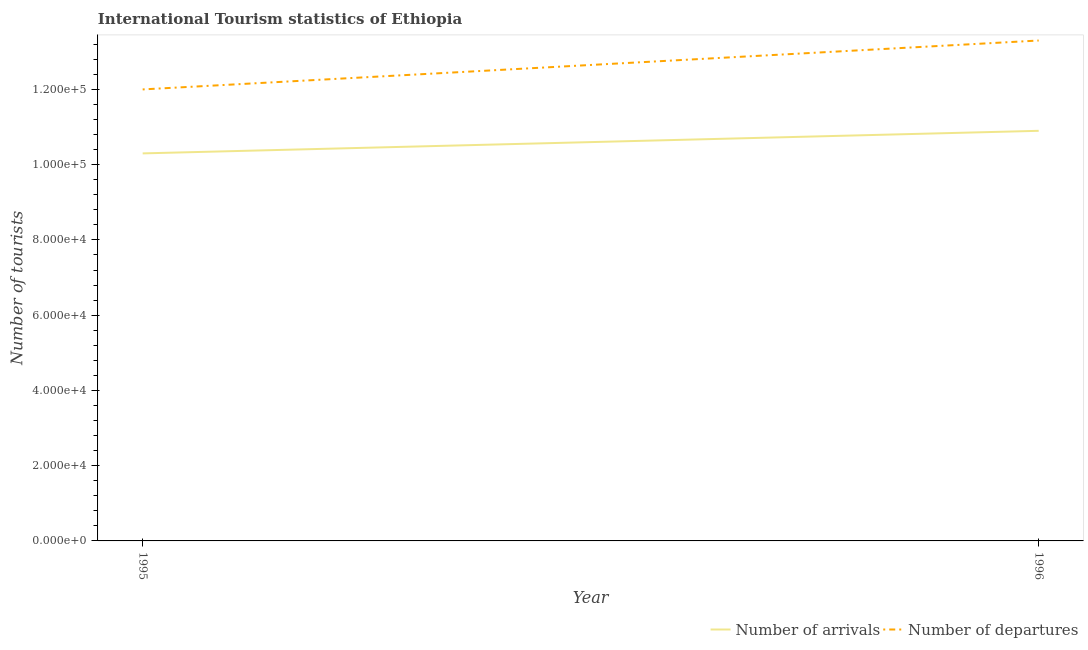How many different coloured lines are there?
Provide a succinct answer. 2. What is the number of tourist arrivals in 1995?
Your answer should be compact. 1.03e+05. Across all years, what is the maximum number of tourist arrivals?
Ensure brevity in your answer.  1.09e+05. Across all years, what is the minimum number of tourist arrivals?
Your answer should be very brief. 1.03e+05. What is the total number of tourist departures in the graph?
Offer a very short reply. 2.53e+05. What is the difference between the number of tourist departures in 1995 and that in 1996?
Offer a very short reply. -1.30e+04. What is the difference between the number of tourist departures in 1996 and the number of tourist arrivals in 1995?
Offer a very short reply. 3.00e+04. What is the average number of tourist departures per year?
Your answer should be very brief. 1.26e+05. In the year 1996, what is the difference between the number of tourist arrivals and number of tourist departures?
Make the answer very short. -2.40e+04. In how many years, is the number of tourist departures greater than 8000?
Ensure brevity in your answer.  2. What is the ratio of the number of tourist arrivals in 1995 to that in 1996?
Your answer should be very brief. 0.94. Is the number of tourist arrivals in 1995 less than that in 1996?
Provide a short and direct response. Yes. In how many years, is the number of tourist departures greater than the average number of tourist departures taken over all years?
Make the answer very short. 1. Does the number of tourist arrivals monotonically increase over the years?
Keep it short and to the point. Yes. Is the number of tourist arrivals strictly less than the number of tourist departures over the years?
Your answer should be very brief. Yes. What is the difference between two consecutive major ticks on the Y-axis?
Provide a short and direct response. 2.00e+04. Where does the legend appear in the graph?
Ensure brevity in your answer.  Bottom right. How many legend labels are there?
Offer a very short reply. 2. What is the title of the graph?
Keep it short and to the point. International Tourism statistics of Ethiopia. What is the label or title of the Y-axis?
Offer a terse response. Number of tourists. What is the Number of tourists in Number of arrivals in 1995?
Offer a very short reply. 1.03e+05. What is the Number of tourists in Number of departures in 1995?
Ensure brevity in your answer.  1.20e+05. What is the Number of tourists in Number of arrivals in 1996?
Ensure brevity in your answer.  1.09e+05. What is the Number of tourists in Number of departures in 1996?
Provide a short and direct response. 1.33e+05. Across all years, what is the maximum Number of tourists in Number of arrivals?
Offer a very short reply. 1.09e+05. Across all years, what is the maximum Number of tourists of Number of departures?
Give a very brief answer. 1.33e+05. Across all years, what is the minimum Number of tourists of Number of arrivals?
Give a very brief answer. 1.03e+05. Across all years, what is the minimum Number of tourists in Number of departures?
Your answer should be very brief. 1.20e+05. What is the total Number of tourists in Number of arrivals in the graph?
Ensure brevity in your answer.  2.12e+05. What is the total Number of tourists in Number of departures in the graph?
Make the answer very short. 2.53e+05. What is the difference between the Number of tourists in Number of arrivals in 1995 and that in 1996?
Give a very brief answer. -6000. What is the difference between the Number of tourists of Number of departures in 1995 and that in 1996?
Provide a short and direct response. -1.30e+04. What is the average Number of tourists in Number of arrivals per year?
Offer a terse response. 1.06e+05. What is the average Number of tourists of Number of departures per year?
Provide a short and direct response. 1.26e+05. In the year 1995, what is the difference between the Number of tourists in Number of arrivals and Number of tourists in Number of departures?
Your answer should be very brief. -1.70e+04. In the year 1996, what is the difference between the Number of tourists in Number of arrivals and Number of tourists in Number of departures?
Keep it short and to the point. -2.40e+04. What is the ratio of the Number of tourists in Number of arrivals in 1995 to that in 1996?
Provide a succinct answer. 0.94. What is the ratio of the Number of tourists of Number of departures in 1995 to that in 1996?
Offer a terse response. 0.9. What is the difference between the highest and the second highest Number of tourists of Number of arrivals?
Ensure brevity in your answer.  6000. What is the difference between the highest and the second highest Number of tourists in Number of departures?
Offer a terse response. 1.30e+04. What is the difference between the highest and the lowest Number of tourists in Number of arrivals?
Your answer should be very brief. 6000. What is the difference between the highest and the lowest Number of tourists of Number of departures?
Your answer should be compact. 1.30e+04. 